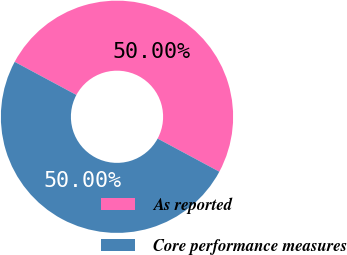<chart> <loc_0><loc_0><loc_500><loc_500><pie_chart><fcel>As reported<fcel>Core performance measures<nl><fcel>50.0%<fcel>50.0%<nl></chart> 